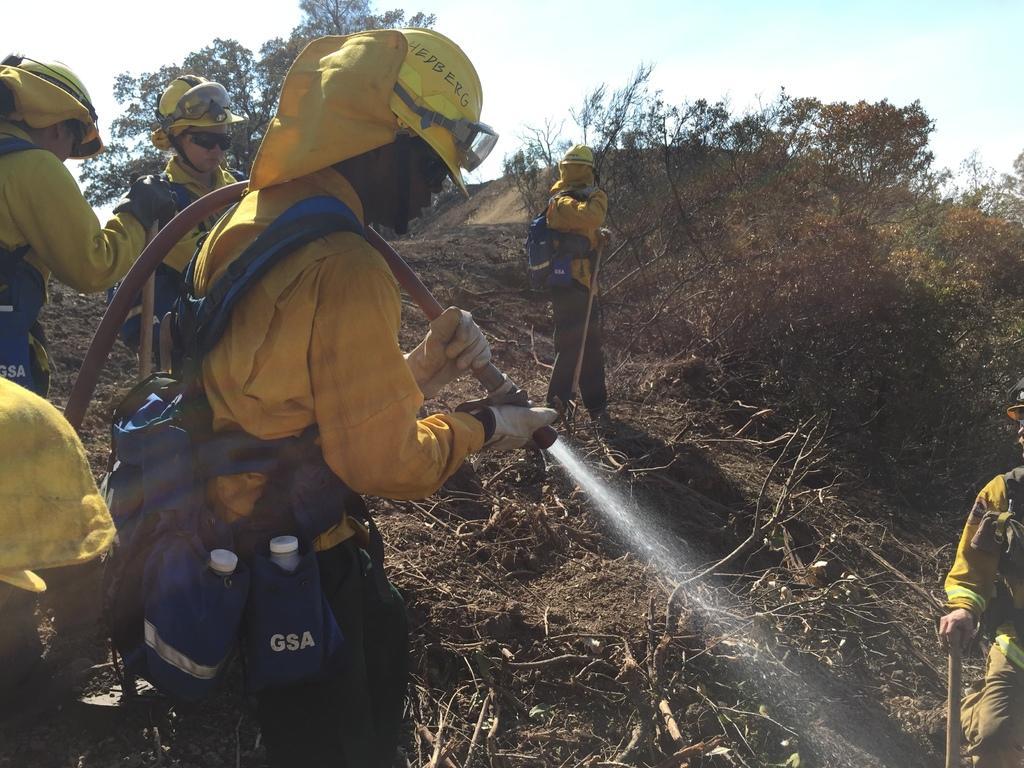Can you describe this image briefly? In the center of the image we can see a few people are standing and they are in different costumes and we can see they are holding some objects. And we can see they are wearing helmets and some objects. On the right side of the image, we can see a person holding some object. On the left side of the image, there is a cloth. In the background, we can see the sky, clouds, trees and branches. 